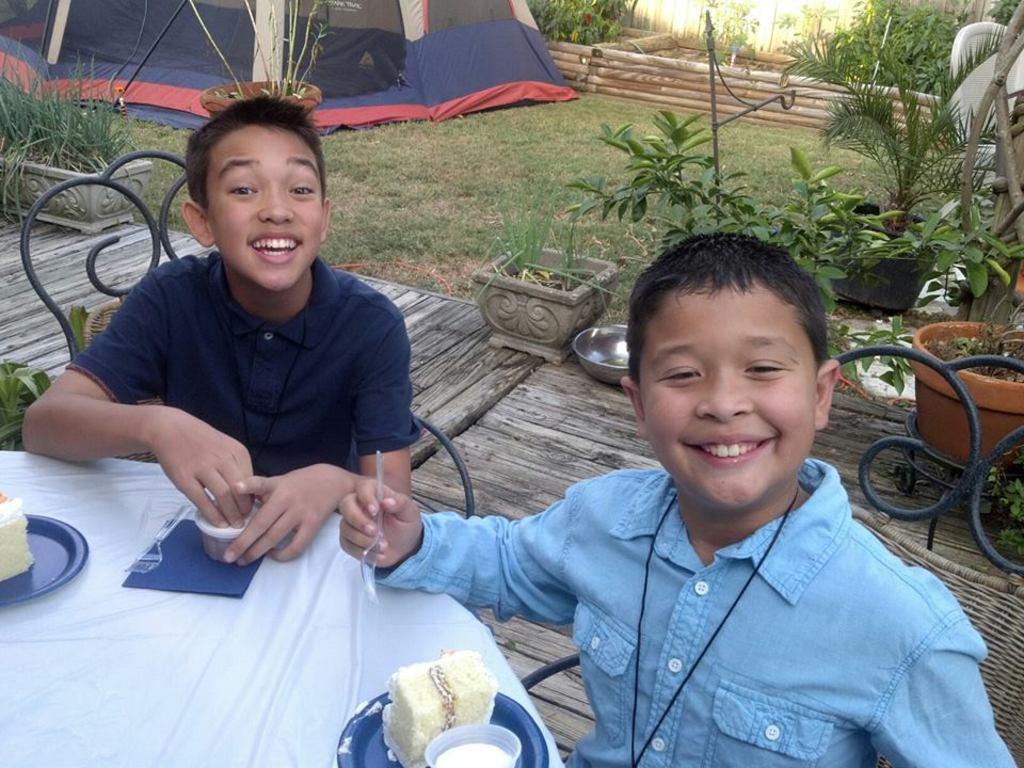Can you describe this image briefly? This picture is of outside. In the foreground we can see two boys sitting on the chairs, smiling and eating food. In the left corner there is a table on the top of which plates of food are placed. In the background we can see the grass, house plants, a tent and a wall. 